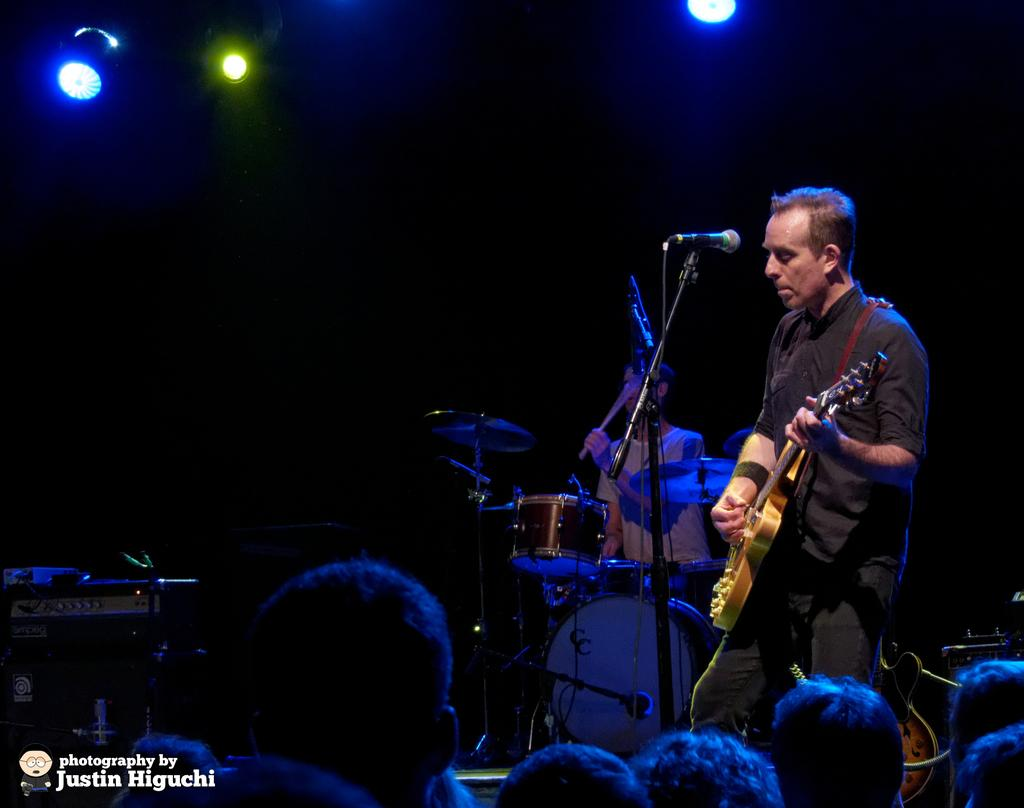What is the person in the image wearing? The person in the image is wearing a black dress. What is the person doing while wearing the black dress? The person is playing a guitar. What is in front of the person playing the guitar? There is a microphone in front of the person playing the guitar. Who else is playing an instrument in the image? There is a person playing drums beside the guitarist. Who is present to watch the musicians play? There are audience members in front of the musicians. What type of toothbrush is the person using to play the guitar in the image? There is no toothbrush present in the image, and the person is not using any object to play the guitar. 